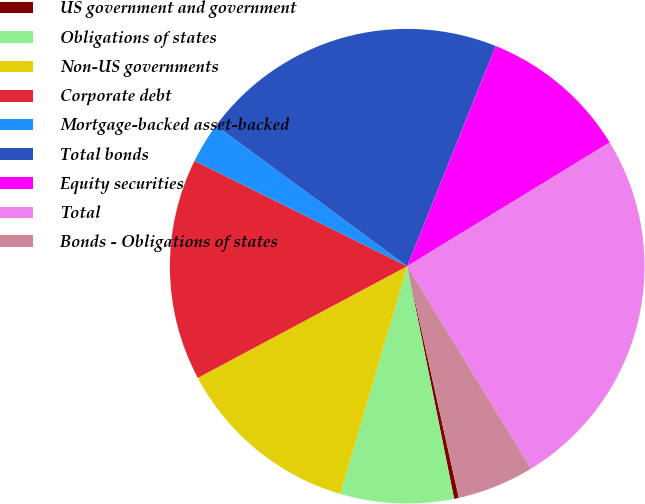Convert chart. <chart><loc_0><loc_0><loc_500><loc_500><pie_chart><fcel>US government and government<fcel>Obligations of states<fcel>Non-US governments<fcel>Corporate debt<fcel>Mortgage-backed asset-backed<fcel>Total bonds<fcel>Equity securities<fcel>Total<fcel>Bonds - Obligations of states<nl><fcel>0.32%<fcel>7.72%<fcel>12.65%<fcel>15.12%<fcel>2.78%<fcel>20.98%<fcel>10.19%<fcel>24.99%<fcel>5.25%<nl></chart> 